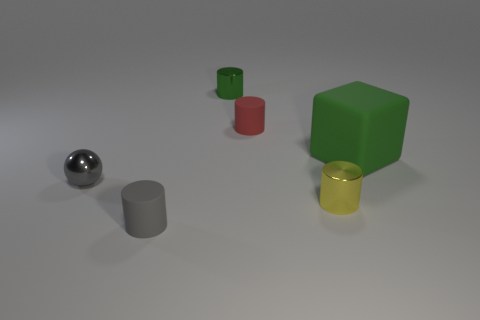Subtract all small green cylinders. How many cylinders are left? 3 Add 1 yellow matte blocks. How many objects exist? 7 Subtract all yellow cylinders. How many cylinders are left? 3 Subtract 1 cubes. How many cubes are left? 0 Subtract all spheres. How many objects are left? 5 Subtract all tiny brown shiny objects. Subtract all gray metal objects. How many objects are left? 5 Add 5 yellow metallic cylinders. How many yellow metallic cylinders are left? 6 Add 2 small cylinders. How many small cylinders exist? 6 Subtract 0 purple cubes. How many objects are left? 6 Subtract all blue blocks. Subtract all blue cylinders. How many blocks are left? 1 